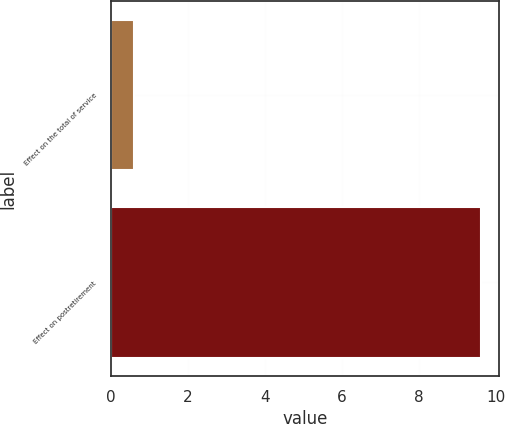Convert chart to OTSL. <chart><loc_0><loc_0><loc_500><loc_500><bar_chart><fcel>Effect on the total of service<fcel>Effect on postretirement<nl><fcel>0.6<fcel>9.6<nl></chart> 